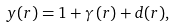<formula> <loc_0><loc_0><loc_500><loc_500>y ( r ) = 1 + \gamma \left ( r \right ) + d ( r ) ,</formula> 